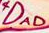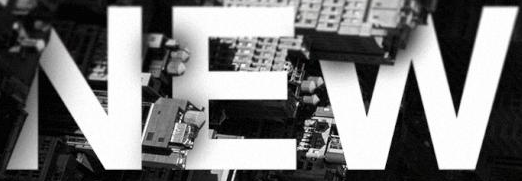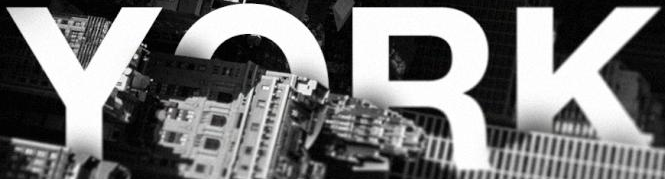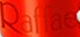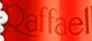What words are shown in these images in order, separated by a semicolon? DAD; NEW; YORK; Raffae; Raffael 